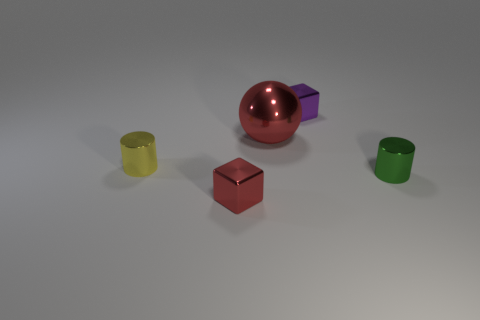Add 5 cylinders. How many objects exist? 10 Subtract all cylinders. How many objects are left? 3 Add 4 tiny purple things. How many tiny purple things exist? 5 Subtract 1 red balls. How many objects are left? 4 Subtract all small purple objects. Subtract all balls. How many objects are left? 3 Add 2 metallic balls. How many metallic balls are left? 3 